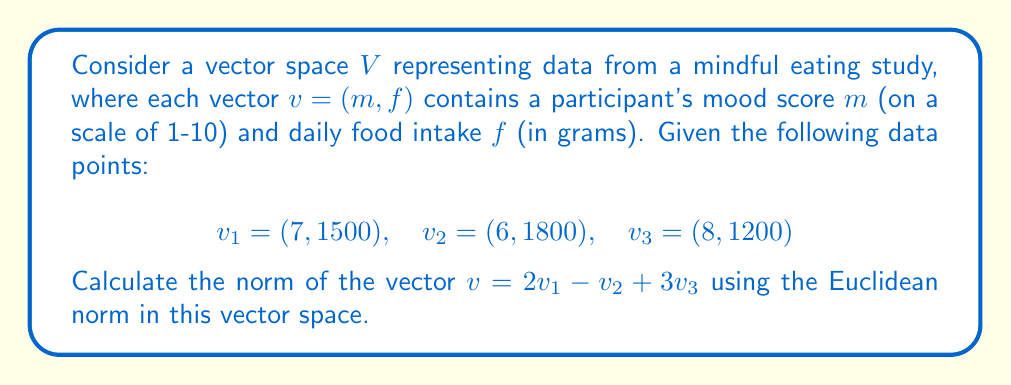Teach me how to tackle this problem. To solve this problem, we'll follow these steps:

1) First, let's calculate the vector $v$:
   $v = 2v_1 - v_2 + 3v_3$
   $= 2(7, 1500) - (6, 1800) + 3(8, 1200)$
   $= (14, 3000) - (6, 1800) + (24, 3600)$
   $= (14-6+24, 3000-1800+3600)$
   $= (32, 4800)$

2) The Euclidean norm of a vector $(x, y)$ is defined as:
   $\|v\| = \sqrt{x^2 + y^2}$

3) Substituting our values:
   $\|v\| = \sqrt{32^2 + 4800^2}$

4) Calculate:
   $\|v\| = \sqrt{1024 + 23,040,000}$
   $= \sqrt{23,041,024}$
   $= 4800.1066...

5) Rounding to two decimal places:
   $\|v\| \approx 4800.11$

This norm represents the magnitude of the combined effect of mood and food intake changes in the study, providing a single metric for the overall change in participant data.
Answer: $\|v\| \approx 4800.11$ 